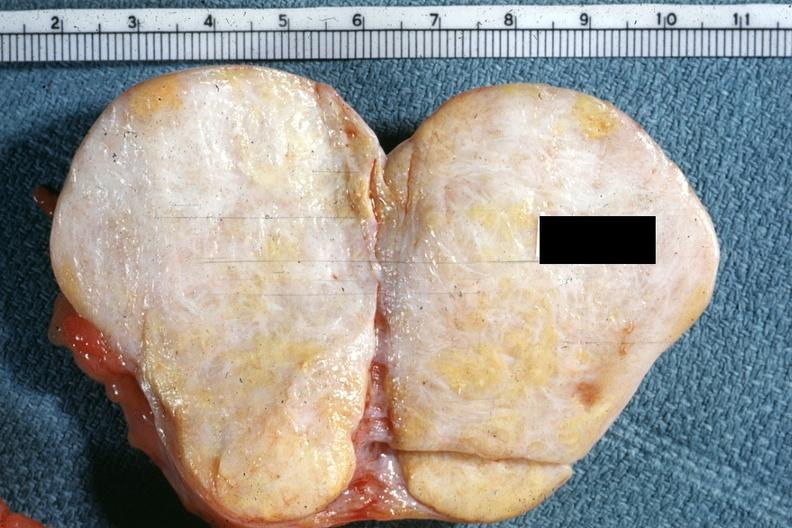s breast no ovary present to indicate the location of the tumor mass?
Answer the question using a single word or phrase. No 